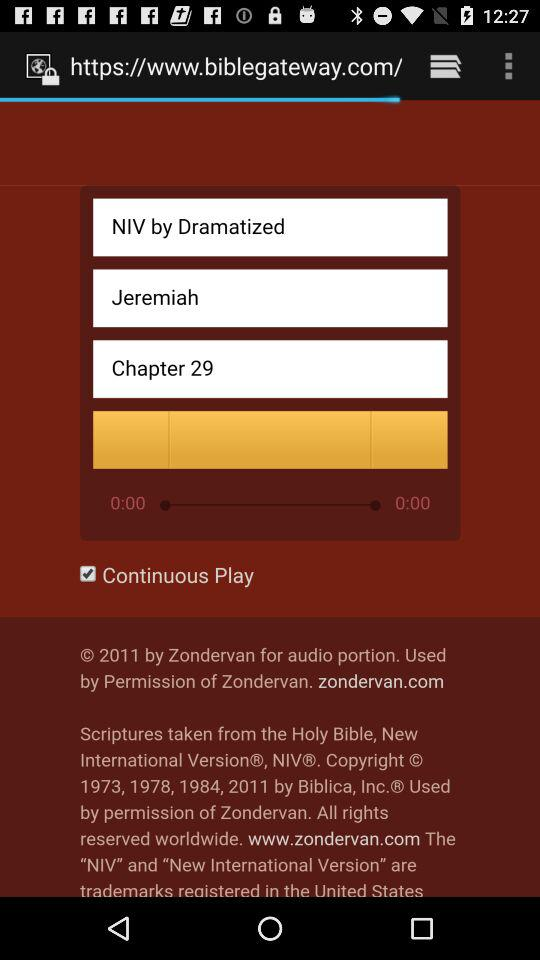What is the title of the chapter?
When the provided information is insufficient, respond with <no answer>. <no answer> 